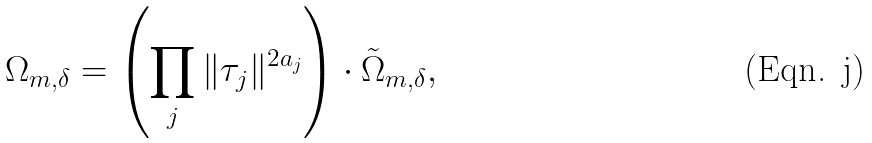<formula> <loc_0><loc_0><loc_500><loc_500>\Omega _ { m , \delta } = \left ( \prod _ { j } \| \tau _ { j } \| ^ { 2 a _ { j } } \right ) \cdot \tilde { \Omega } _ { m , \delta } ,</formula> 